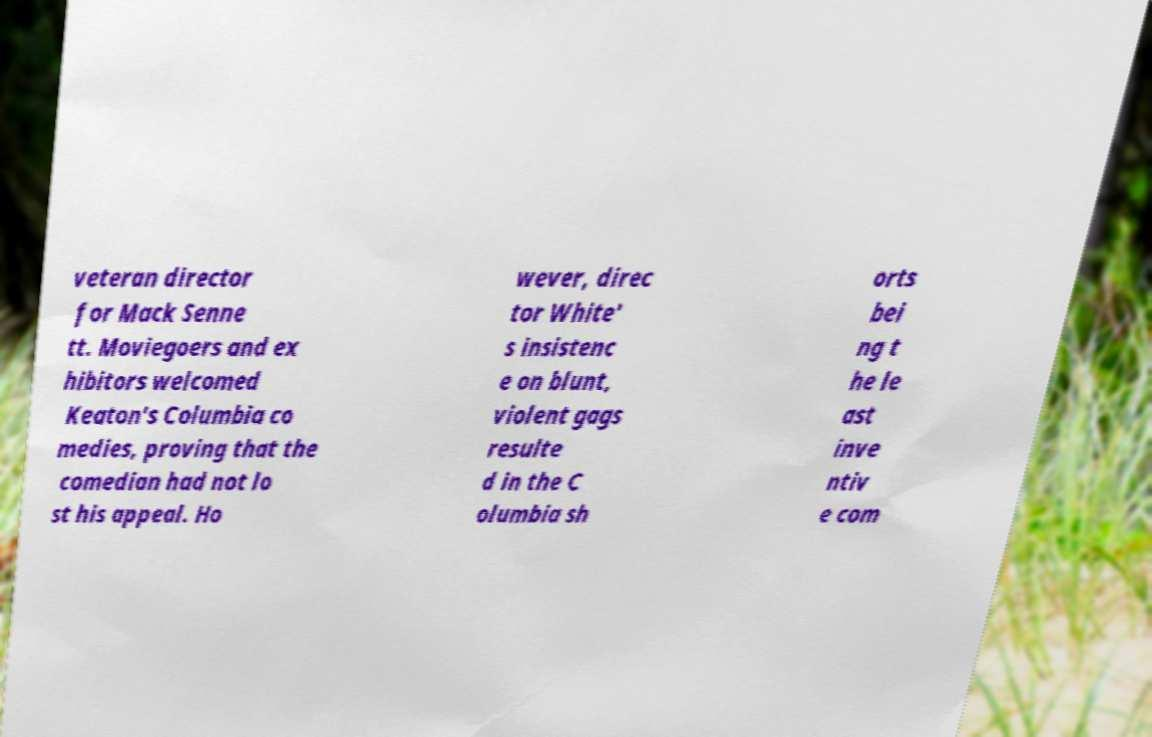Can you read and provide the text displayed in the image?This photo seems to have some interesting text. Can you extract and type it out for me? veteran director for Mack Senne tt. Moviegoers and ex hibitors welcomed Keaton's Columbia co medies, proving that the comedian had not lo st his appeal. Ho wever, direc tor White' s insistenc e on blunt, violent gags resulte d in the C olumbia sh orts bei ng t he le ast inve ntiv e com 